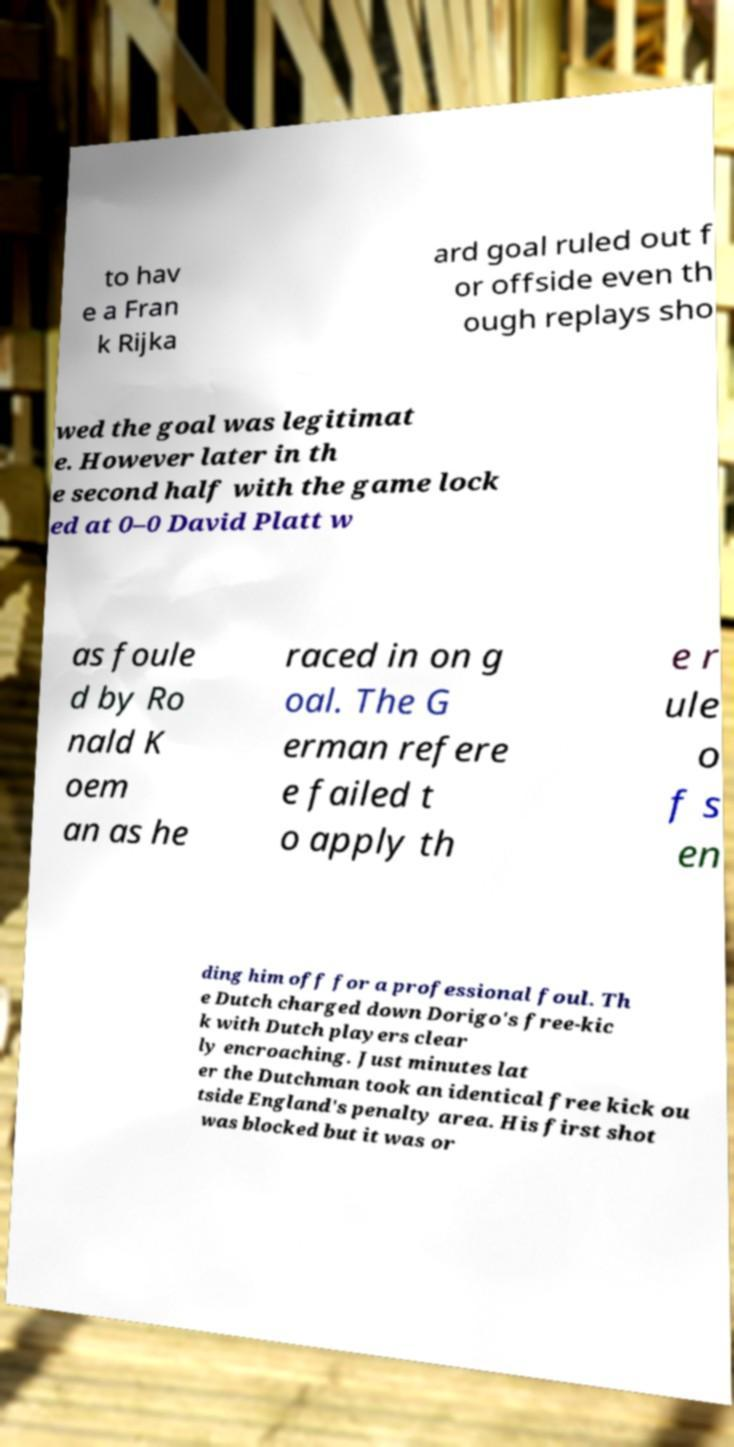Could you extract and type out the text from this image? to hav e a Fran k Rijka ard goal ruled out f or offside even th ough replays sho wed the goal was legitimat e. However later in th e second half with the game lock ed at 0–0 David Platt w as foule d by Ro nald K oem an as he raced in on g oal. The G erman refere e failed t o apply th e r ule o f s en ding him off for a professional foul. Th e Dutch charged down Dorigo's free-kic k with Dutch players clear ly encroaching. Just minutes lat er the Dutchman took an identical free kick ou tside England's penalty area. His first shot was blocked but it was or 